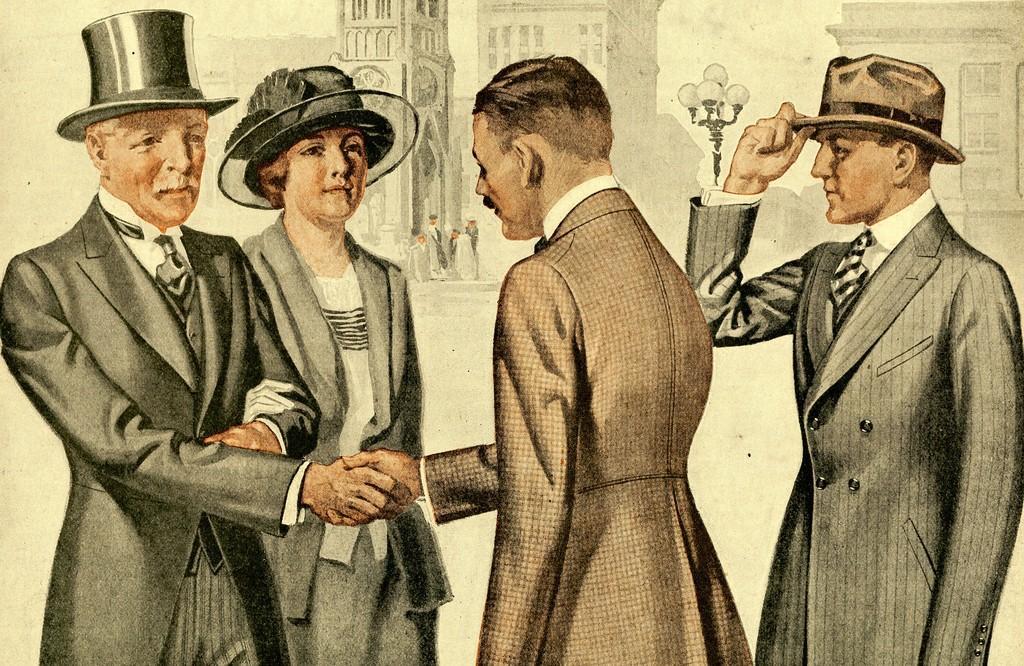In one or two sentences, can you explain what this image depicts? It is a painted image. In front of the image there are two people shaking their hands. Behind them there are two other people. In the background of the image there are lights. There are people. There are buildings. 